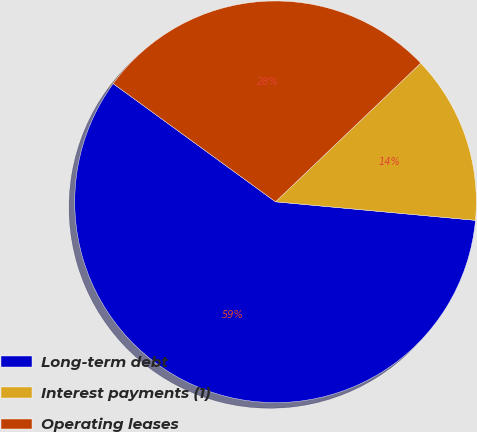Convert chart to OTSL. <chart><loc_0><loc_0><loc_500><loc_500><pie_chart><fcel>Long-term debt<fcel>Interest payments (1)<fcel>Operating leases<nl><fcel>58.54%<fcel>13.6%<fcel>27.85%<nl></chart> 